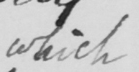Please provide the text content of this handwritten line. which 